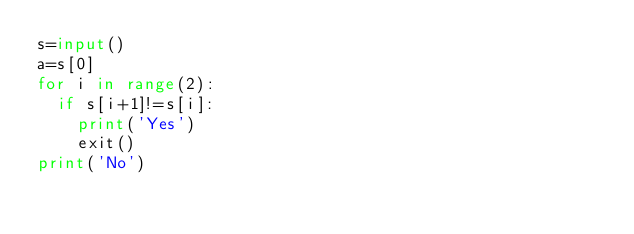<code> <loc_0><loc_0><loc_500><loc_500><_Python_>s=input()
a=s[0]
for i in range(2):
  if s[i+1]!=s[i]:
    print('Yes')
    exit()
print('No')</code> 